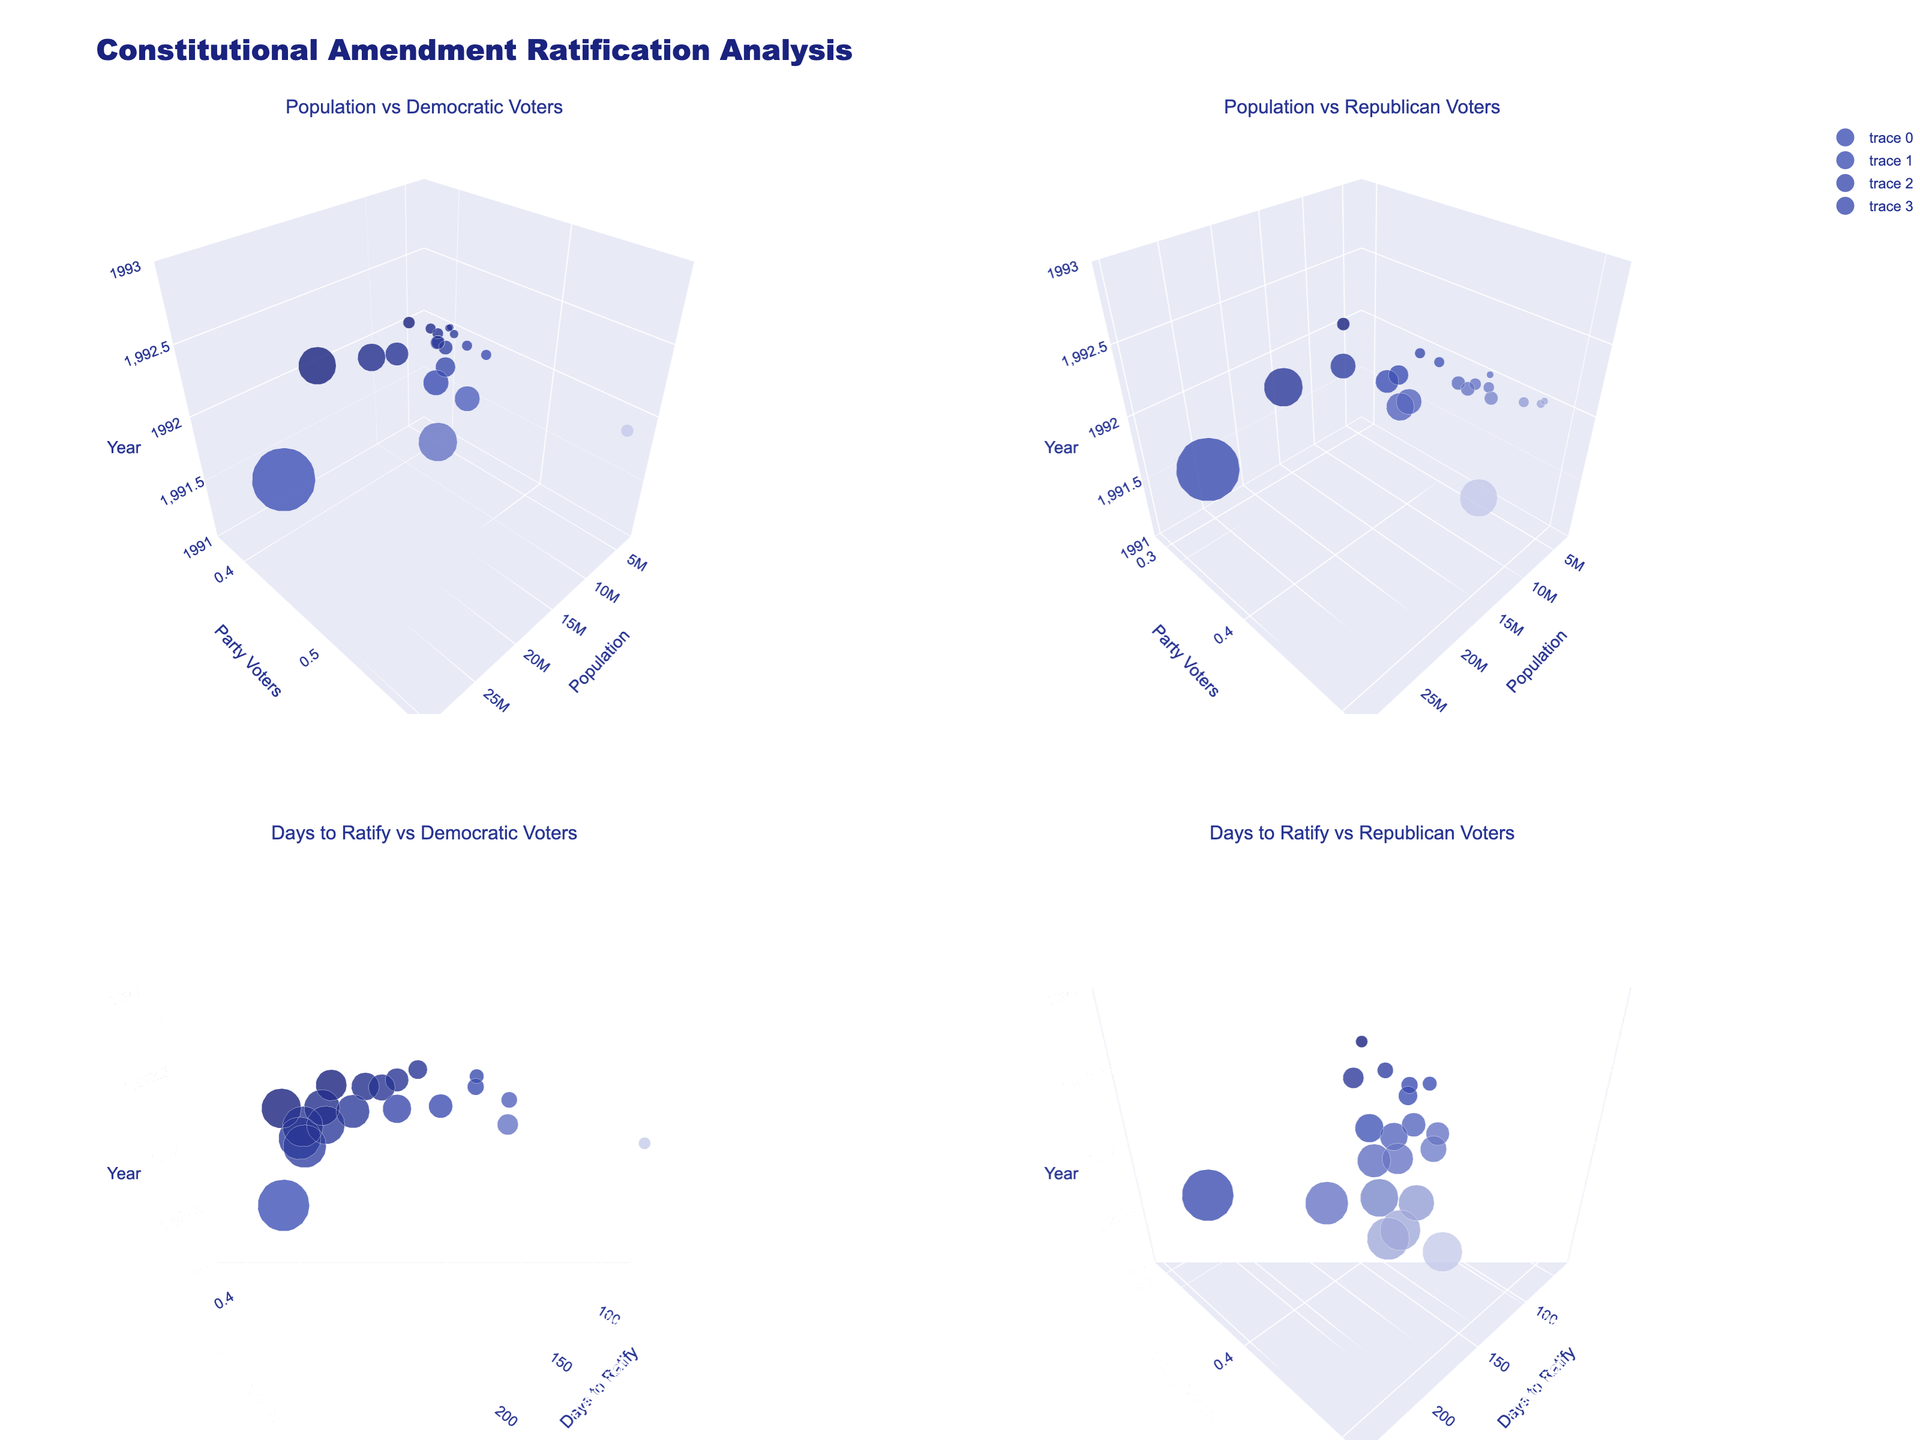What is the title of the overall figure? The title is located at the top of the overall plot and is styled in a larger font compared to other texts. From the provided data and code, the title is "Constitutional Amendment Ratification Analysis".
Answer: Constitutional Amendment Ratification Analysis Which state had the smallest population in the subplot "Population vs Democratic Voters"? In the "Population vs Democratic Voters" subplot, the size of the markers indicates the population size, with smaller markers representing smaller populations. From the data, Colorado has the smallest population.
Answer: Colorado In the "Days to Ratify vs Democratic Voters" subplot, which state ratified the amendment the fastest? To find the fastest ratification, we look for the state with the smallest number of days to ratify (x-axis). From the data, Massachusetts ratified the amendment in the fewest days (56 days).
Answer: Massachusetts How does the percentage of Democratic voters compare between Texas and New York in 1992? By comparing the y-values for Texas and New York in any subplot with Democratic voters on the y-axis, we see that New York has a higher percentage of Democratic voters (0.50) than Texas (0.37).
Answer: New York has a higher percentage In the "Population vs Republican Voters" subplot, which state had the highest percentage of Republican voters? The state with the highest y-value in the "Population vs Republican Voters" subplot represents the highest percentage of Republican voters. According to the data, Alabama has the highest percentage (0.48).
Answer: Alabama On average, how many days did it take for states with more than 40% Democratic voters to ratify the amendment? First, identify states with more than 40% Democratic voters. Then, sum the days to ratify for these states and divide by the number of such states. The relevant states and their days are: California (242), New York (98), Illinois (75), Pennsylvania (112), Michigan (67), Wisconsin (78), and Massachusetts (56). The average is (242 + 98 + 75 + 112 + 67 + 78 + 56) / 7 = 104 days.
Answer: 104 days Is there any correlation between population size and days to ratify in the given data? To determine this, compare subplots to see if states with larger population sizes tend to have more or fewer days to ratify on average. However, the figure suggests no visible strong correlation between these two variables, as there is no clear pattern aligning population size with days to ratify.
Answer: No strong correlation Which subplot shows the relationship between the number of days to ratify the amendment and the percentage of Democratic voters across states? This information is part of the subplot titles. The subplot titled "Days to Ratify vs Democratic Voters" shows this relationship.
Answer: Days to Ratify vs Democratic Voters What is the size of the marker for California in the "Population vs Republican Voters" subplot? Marker sizes are proportional to the population size divided by 500,000. California's population is 29,760,021. The size is approximately 29,760,021 / 500,000 = 59.52. Thus, it will be a large marker in the subplot.
Answer: Approximately 59.52 